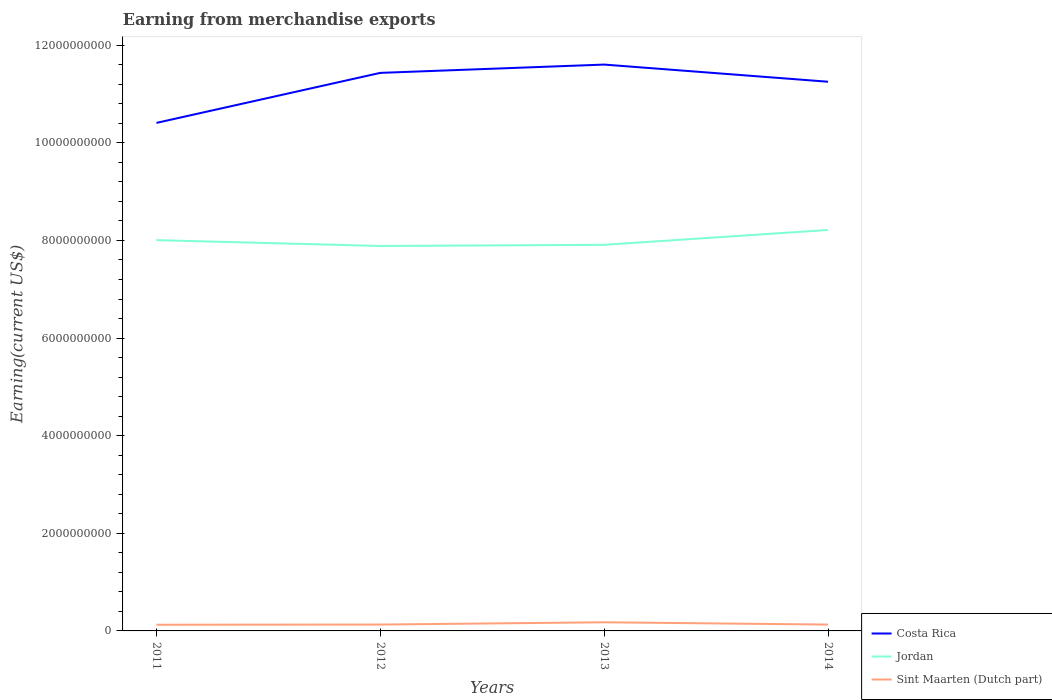Across all years, what is the maximum amount earned from merchandise exports in Jordan?
Your response must be concise. 7.89e+09. What is the total amount earned from merchandise exports in Costa Rica in the graph?
Offer a terse response. 1.82e+08. What is the difference between the highest and the second highest amount earned from merchandise exports in Costa Rica?
Offer a terse response. 1.19e+09. How many years are there in the graph?
Give a very brief answer. 4. Are the values on the major ticks of Y-axis written in scientific E-notation?
Your response must be concise. No. Does the graph contain grids?
Provide a short and direct response. No. Where does the legend appear in the graph?
Provide a succinct answer. Bottom right. How many legend labels are there?
Offer a terse response. 3. What is the title of the graph?
Your response must be concise. Earning from merchandise exports. Does "Iceland" appear as one of the legend labels in the graph?
Provide a succinct answer. No. What is the label or title of the Y-axis?
Provide a short and direct response. Earning(current US$). What is the Earning(current US$) of Costa Rica in 2011?
Your response must be concise. 1.04e+1. What is the Earning(current US$) of Jordan in 2011?
Offer a very short reply. 8.01e+09. What is the Earning(current US$) of Sint Maarten (Dutch part) in 2011?
Provide a short and direct response. 1.27e+08. What is the Earning(current US$) of Costa Rica in 2012?
Offer a very short reply. 1.14e+1. What is the Earning(current US$) of Jordan in 2012?
Keep it short and to the point. 7.89e+09. What is the Earning(current US$) in Sint Maarten (Dutch part) in 2012?
Provide a short and direct response. 1.31e+08. What is the Earning(current US$) in Costa Rica in 2013?
Offer a terse response. 1.16e+1. What is the Earning(current US$) of Jordan in 2013?
Make the answer very short. 7.91e+09. What is the Earning(current US$) in Sint Maarten (Dutch part) in 2013?
Your answer should be very brief. 1.77e+08. What is the Earning(current US$) in Costa Rica in 2014?
Provide a succinct answer. 1.13e+1. What is the Earning(current US$) of Jordan in 2014?
Your response must be concise. 8.22e+09. What is the Earning(current US$) of Sint Maarten (Dutch part) in 2014?
Provide a succinct answer. 1.30e+08. Across all years, what is the maximum Earning(current US$) in Costa Rica?
Ensure brevity in your answer.  1.16e+1. Across all years, what is the maximum Earning(current US$) of Jordan?
Your response must be concise. 8.22e+09. Across all years, what is the maximum Earning(current US$) of Sint Maarten (Dutch part)?
Offer a very short reply. 1.77e+08. Across all years, what is the minimum Earning(current US$) in Costa Rica?
Your answer should be compact. 1.04e+1. Across all years, what is the minimum Earning(current US$) in Jordan?
Make the answer very short. 7.89e+09. Across all years, what is the minimum Earning(current US$) of Sint Maarten (Dutch part)?
Provide a short and direct response. 1.27e+08. What is the total Earning(current US$) in Costa Rica in the graph?
Offer a very short reply. 4.47e+1. What is the total Earning(current US$) of Jordan in the graph?
Your answer should be very brief. 3.20e+1. What is the total Earning(current US$) of Sint Maarten (Dutch part) in the graph?
Provide a short and direct response. 5.65e+08. What is the difference between the Earning(current US$) of Costa Rica in 2011 and that in 2012?
Provide a short and direct response. -1.02e+09. What is the difference between the Earning(current US$) of Jordan in 2011 and that in 2012?
Give a very brief answer. 1.20e+08. What is the difference between the Earning(current US$) of Sint Maarten (Dutch part) in 2011 and that in 2012?
Make the answer very short. -3.82e+06. What is the difference between the Earning(current US$) of Costa Rica in 2011 and that in 2013?
Your answer should be compact. -1.19e+09. What is the difference between the Earning(current US$) in Jordan in 2011 and that in 2013?
Your response must be concise. 9.57e+07. What is the difference between the Earning(current US$) of Sint Maarten (Dutch part) in 2011 and that in 2013?
Offer a terse response. -5.01e+07. What is the difference between the Earning(current US$) of Costa Rica in 2011 and that in 2014?
Give a very brief answer. -8.43e+08. What is the difference between the Earning(current US$) of Jordan in 2011 and that in 2014?
Provide a short and direct response. -2.09e+08. What is the difference between the Earning(current US$) in Sint Maarten (Dutch part) in 2011 and that in 2014?
Your answer should be compact. -3.09e+06. What is the difference between the Earning(current US$) in Costa Rica in 2012 and that in 2013?
Your answer should be very brief. -1.70e+08. What is the difference between the Earning(current US$) in Jordan in 2012 and that in 2013?
Give a very brief answer. -2.41e+07. What is the difference between the Earning(current US$) of Sint Maarten (Dutch part) in 2012 and that in 2013?
Your answer should be compact. -4.63e+07. What is the difference between the Earning(current US$) in Costa Rica in 2012 and that in 2014?
Your response must be concise. 1.82e+08. What is the difference between the Earning(current US$) of Jordan in 2012 and that in 2014?
Provide a short and direct response. -3.28e+08. What is the difference between the Earning(current US$) in Sint Maarten (Dutch part) in 2012 and that in 2014?
Make the answer very short. 7.26e+05. What is the difference between the Earning(current US$) of Costa Rica in 2013 and that in 2014?
Give a very brief answer. 3.51e+08. What is the difference between the Earning(current US$) of Jordan in 2013 and that in 2014?
Give a very brief answer. -3.04e+08. What is the difference between the Earning(current US$) in Sint Maarten (Dutch part) in 2013 and that in 2014?
Your answer should be very brief. 4.70e+07. What is the difference between the Earning(current US$) of Costa Rica in 2011 and the Earning(current US$) of Jordan in 2012?
Offer a terse response. 2.52e+09. What is the difference between the Earning(current US$) of Costa Rica in 2011 and the Earning(current US$) of Sint Maarten (Dutch part) in 2012?
Provide a short and direct response. 1.03e+1. What is the difference between the Earning(current US$) of Jordan in 2011 and the Earning(current US$) of Sint Maarten (Dutch part) in 2012?
Make the answer very short. 7.88e+09. What is the difference between the Earning(current US$) in Costa Rica in 2011 and the Earning(current US$) in Jordan in 2013?
Make the answer very short. 2.50e+09. What is the difference between the Earning(current US$) in Costa Rica in 2011 and the Earning(current US$) in Sint Maarten (Dutch part) in 2013?
Keep it short and to the point. 1.02e+1. What is the difference between the Earning(current US$) in Jordan in 2011 and the Earning(current US$) in Sint Maarten (Dutch part) in 2013?
Your response must be concise. 7.83e+09. What is the difference between the Earning(current US$) of Costa Rica in 2011 and the Earning(current US$) of Jordan in 2014?
Give a very brief answer. 2.19e+09. What is the difference between the Earning(current US$) in Costa Rica in 2011 and the Earning(current US$) in Sint Maarten (Dutch part) in 2014?
Your response must be concise. 1.03e+1. What is the difference between the Earning(current US$) of Jordan in 2011 and the Earning(current US$) of Sint Maarten (Dutch part) in 2014?
Provide a short and direct response. 7.88e+09. What is the difference between the Earning(current US$) of Costa Rica in 2012 and the Earning(current US$) of Jordan in 2013?
Offer a terse response. 3.52e+09. What is the difference between the Earning(current US$) of Costa Rica in 2012 and the Earning(current US$) of Sint Maarten (Dutch part) in 2013?
Keep it short and to the point. 1.13e+1. What is the difference between the Earning(current US$) in Jordan in 2012 and the Earning(current US$) in Sint Maarten (Dutch part) in 2013?
Ensure brevity in your answer.  7.71e+09. What is the difference between the Earning(current US$) in Costa Rica in 2012 and the Earning(current US$) in Jordan in 2014?
Your response must be concise. 3.22e+09. What is the difference between the Earning(current US$) in Costa Rica in 2012 and the Earning(current US$) in Sint Maarten (Dutch part) in 2014?
Your answer should be compact. 1.13e+1. What is the difference between the Earning(current US$) in Jordan in 2012 and the Earning(current US$) in Sint Maarten (Dutch part) in 2014?
Ensure brevity in your answer.  7.76e+09. What is the difference between the Earning(current US$) of Costa Rica in 2013 and the Earning(current US$) of Jordan in 2014?
Ensure brevity in your answer.  3.39e+09. What is the difference between the Earning(current US$) in Costa Rica in 2013 and the Earning(current US$) in Sint Maarten (Dutch part) in 2014?
Your answer should be compact. 1.15e+1. What is the difference between the Earning(current US$) in Jordan in 2013 and the Earning(current US$) in Sint Maarten (Dutch part) in 2014?
Your answer should be compact. 7.78e+09. What is the average Earning(current US$) of Costa Rica per year?
Your answer should be very brief. 1.12e+1. What is the average Earning(current US$) of Jordan per year?
Provide a short and direct response. 8.00e+09. What is the average Earning(current US$) of Sint Maarten (Dutch part) per year?
Your answer should be very brief. 1.41e+08. In the year 2011, what is the difference between the Earning(current US$) of Costa Rica and Earning(current US$) of Jordan?
Ensure brevity in your answer.  2.40e+09. In the year 2011, what is the difference between the Earning(current US$) of Costa Rica and Earning(current US$) of Sint Maarten (Dutch part)?
Provide a short and direct response. 1.03e+1. In the year 2011, what is the difference between the Earning(current US$) in Jordan and Earning(current US$) in Sint Maarten (Dutch part)?
Your response must be concise. 7.88e+09. In the year 2012, what is the difference between the Earning(current US$) in Costa Rica and Earning(current US$) in Jordan?
Provide a succinct answer. 3.55e+09. In the year 2012, what is the difference between the Earning(current US$) in Costa Rica and Earning(current US$) in Sint Maarten (Dutch part)?
Your answer should be very brief. 1.13e+1. In the year 2012, what is the difference between the Earning(current US$) in Jordan and Earning(current US$) in Sint Maarten (Dutch part)?
Offer a terse response. 7.76e+09. In the year 2013, what is the difference between the Earning(current US$) of Costa Rica and Earning(current US$) of Jordan?
Give a very brief answer. 3.69e+09. In the year 2013, what is the difference between the Earning(current US$) of Costa Rica and Earning(current US$) of Sint Maarten (Dutch part)?
Your response must be concise. 1.14e+1. In the year 2013, what is the difference between the Earning(current US$) in Jordan and Earning(current US$) in Sint Maarten (Dutch part)?
Your answer should be very brief. 7.73e+09. In the year 2014, what is the difference between the Earning(current US$) in Costa Rica and Earning(current US$) in Jordan?
Offer a terse response. 3.04e+09. In the year 2014, what is the difference between the Earning(current US$) in Costa Rica and Earning(current US$) in Sint Maarten (Dutch part)?
Offer a very short reply. 1.11e+1. In the year 2014, what is the difference between the Earning(current US$) in Jordan and Earning(current US$) in Sint Maarten (Dutch part)?
Provide a short and direct response. 8.08e+09. What is the ratio of the Earning(current US$) of Costa Rica in 2011 to that in 2012?
Give a very brief answer. 0.91. What is the ratio of the Earning(current US$) of Jordan in 2011 to that in 2012?
Give a very brief answer. 1.02. What is the ratio of the Earning(current US$) of Sint Maarten (Dutch part) in 2011 to that in 2012?
Your answer should be very brief. 0.97. What is the ratio of the Earning(current US$) in Costa Rica in 2011 to that in 2013?
Make the answer very short. 0.9. What is the ratio of the Earning(current US$) in Jordan in 2011 to that in 2013?
Make the answer very short. 1.01. What is the ratio of the Earning(current US$) in Sint Maarten (Dutch part) in 2011 to that in 2013?
Ensure brevity in your answer.  0.72. What is the ratio of the Earning(current US$) in Costa Rica in 2011 to that in 2014?
Make the answer very short. 0.93. What is the ratio of the Earning(current US$) of Jordan in 2011 to that in 2014?
Provide a succinct answer. 0.97. What is the ratio of the Earning(current US$) in Sint Maarten (Dutch part) in 2011 to that in 2014?
Make the answer very short. 0.98. What is the ratio of the Earning(current US$) in Costa Rica in 2012 to that in 2013?
Give a very brief answer. 0.99. What is the ratio of the Earning(current US$) in Sint Maarten (Dutch part) in 2012 to that in 2013?
Ensure brevity in your answer.  0.74. What is the ratio of the Earning(current US$) of Costa Rica in 2012 to that in 2014?
Provide a succinct answer. 1.02. What is the ratio of the Earning(current US$) in Sint Maarten (Dutch part) in 2012 to that in 2014?
Offer a terse response. 1.01. What is the ratio of the Earning(current US$) of Costa Rica in 2013 to that in 2014?
Offer a very short reply. 1.03. What is the ratio of the Earning(current US$) of Jordan in 2013 to that in 2014?
Offer a terse response. 0.96. What is the ratio of the Earning(current US$) of Sint Maarten (Dutch part) in 2013 to that in 2014?
Keep it short and to the point. 1.36. What is the difference between the highest and the second highest Earning(current US$) in Costa Rica?
Your answer should be compact. 1.70e+08. What is the difference between the highest and the second highest Earning(current US$) of Jordan?
Keep it short and to the point. 2.09e+08. What is the difference between the highest and the second highest Earning(current US$) in Sint Maarten (Dutch part)?
Your answer should be very brief. 4.63e+07. What is the difference between the highest and the lowest Earning(current US$) of Costa Rica?
Offer a terse response. 1.19e+09. What is the difference between the highest and the lowest Earning(current US$) in Jordan?
Keep it short and to the point. 3.28e+08. What is the difference between the highest and the lowest Earning(current US$) in Sint Maarten (Dutch part)?
Provide a succinct answer. 5.01e+07. 